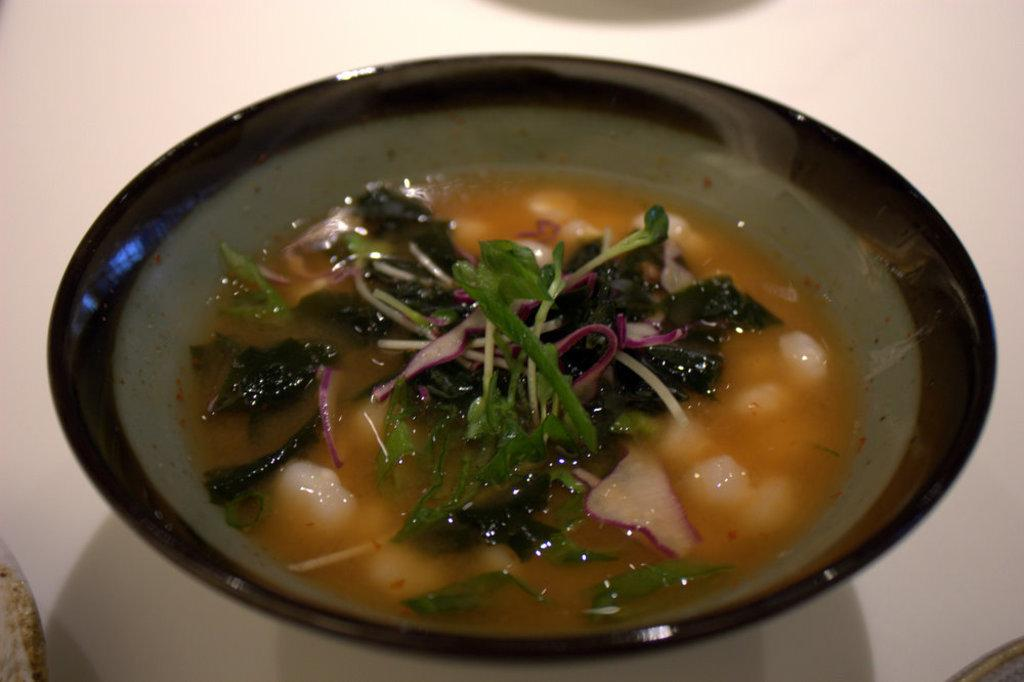What is present in the image? There is a bowl in the image. What is inside the bowl? The bowl contains food items. Is your uncle holding a plate in the image? There is no mention of an uncle or a plate in the provided facts, so we cannot answer this question based on the image. 